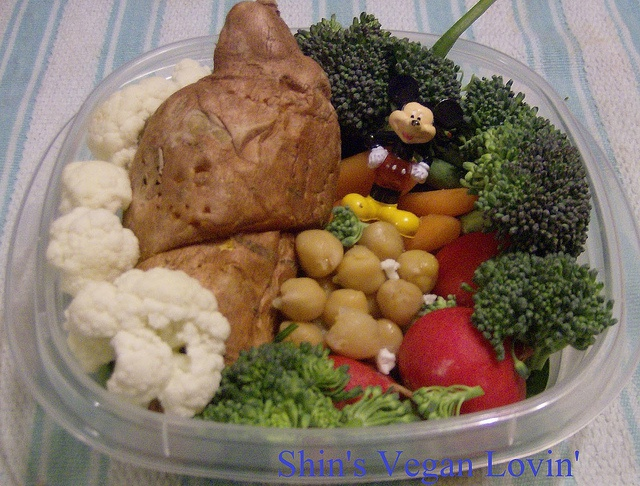Describe the objects in this image and their specific colors. I can see bowl in darkgray, black, olive, and gray tones, dining table in darkgray and gray tones, broccoli in darkgray, black, darkgreen, and gray tones, broccoli in darkgray, darkgreen, black, and olive tones, and apple in darkgray, brown, and maroon tones in this image. 